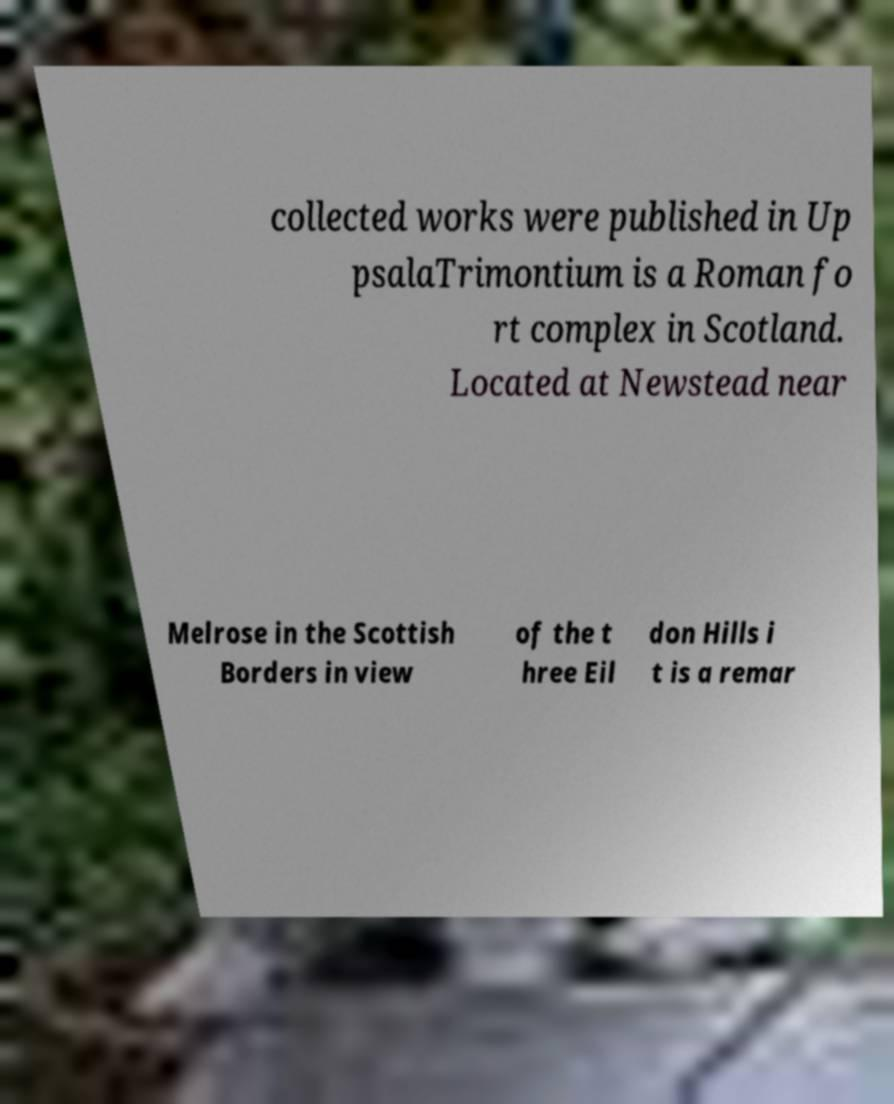Please read and relay the text visible in this image. What does it say? collected works were published in Up psalaTrimontium is a Roman fo rt complex in Scotland. Located at Newstead near Melrose in the Scottish Borders in view of the t hree Eil don Hills i t is a remar 